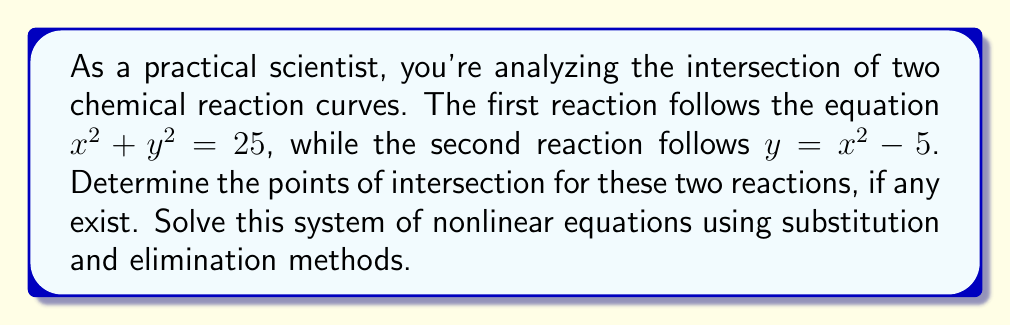Teach me how to tackle this problem. Let's approach this problem systematically:

1) We have two equations:
   $x^2 + y^2 = 25$ (Equation 1)
   $y = x^2 - 5$ (Equation 2)

2) We'll use substitution by replacing $y$ in Equation 1 with the expression from Equation 2:

   $x^2 + (x^2 - 5)^2 = 25$

3) Expand the squared term:
   $x^2 + (x^4 - 10x^2 + 25) = 25$

4) Simplify:
   $x^4 - 9x^2 + 25 = 25$

5) Subtract 25 from both sides:
   $x^4 - 9x^2 = 0$

6) Factor out $x^2$:
   $x^2(x^2 - 9) = 0$

7) Use the zero product property:
   $x^2 = 0$ or $x^2 - 9 = 0$

8) Solve each equation:
   From $x^2 = 0$: $x = 0$
   From $x^2 - 9 = 0$: $x^2 = 9$, so $x = \pm 3$

9) Now that we have the $x$ values, substitute them back into Equation 2 to find the corresponding $y$ values:

   For $x = 0$: $y = 0^2 - 5 = -5$
   For $x = 3$: $y = 3^2 - 5 = 4$
   For $x = -3$: $y = (-3)^2 - 5 = 4$

10) Therefore, the points of intersection are $(0, -5)$, $(3, 4)$, and $(-3, 4)$.

11) Verify by substituting these points into both original equations.
Answer: The system of nonlinear equations has three points of intersection: $(0, -5)$, $(3, 4)$, and $(-3, 4)$. 